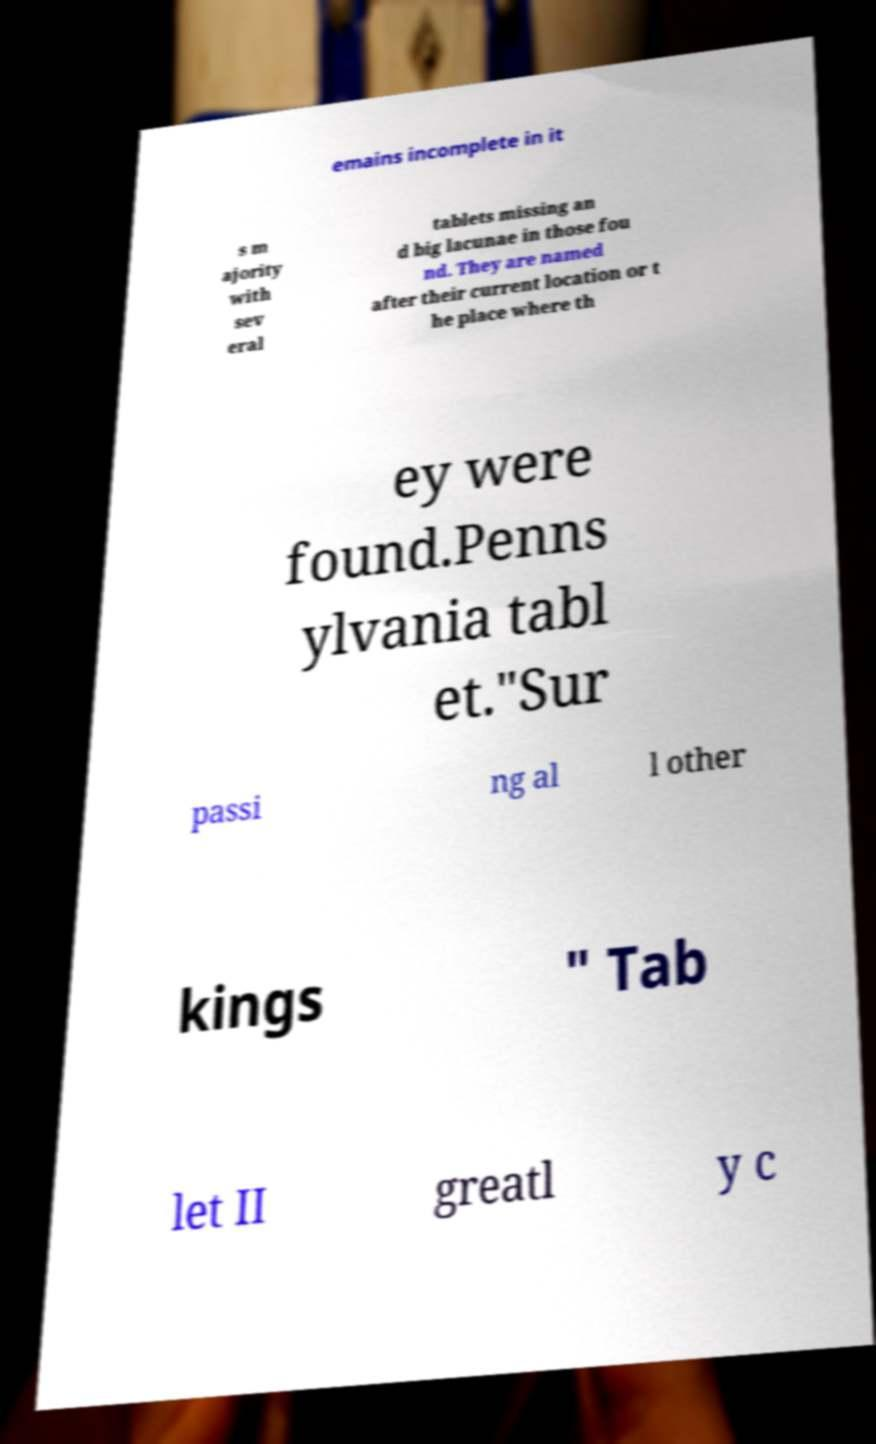Can you accurately transcribe the text from the provided image for me? emains incomplete in it s m ajority with sev eral tablets missing an d big lacunae in those fou nd. They are named after their current location or t he place where th ey were found.Penns ylvania tabl et."Sur passi ng al l other kings " Tab let II greatl y c 